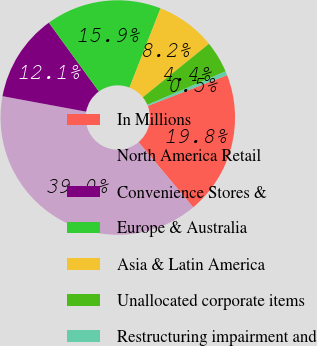Convert chart. <chart><loc_0><loc_0><loc_500><loc_500><pie_chart><fcel>In Millions<fcel>North America Retail<fcel>Convenience Stores &<fcel>Europe & Australia<fcel>Asia & Latin America<fcel>Unallocated corporate items<fcel>Restructuring impairment and<nl><fcel>19.78%<fcel>39.03%<fcel>12.09%<fcel>15.94%<fcel>8.24%<fcel>4.39%<fcel>0.54%<nl></chart> 